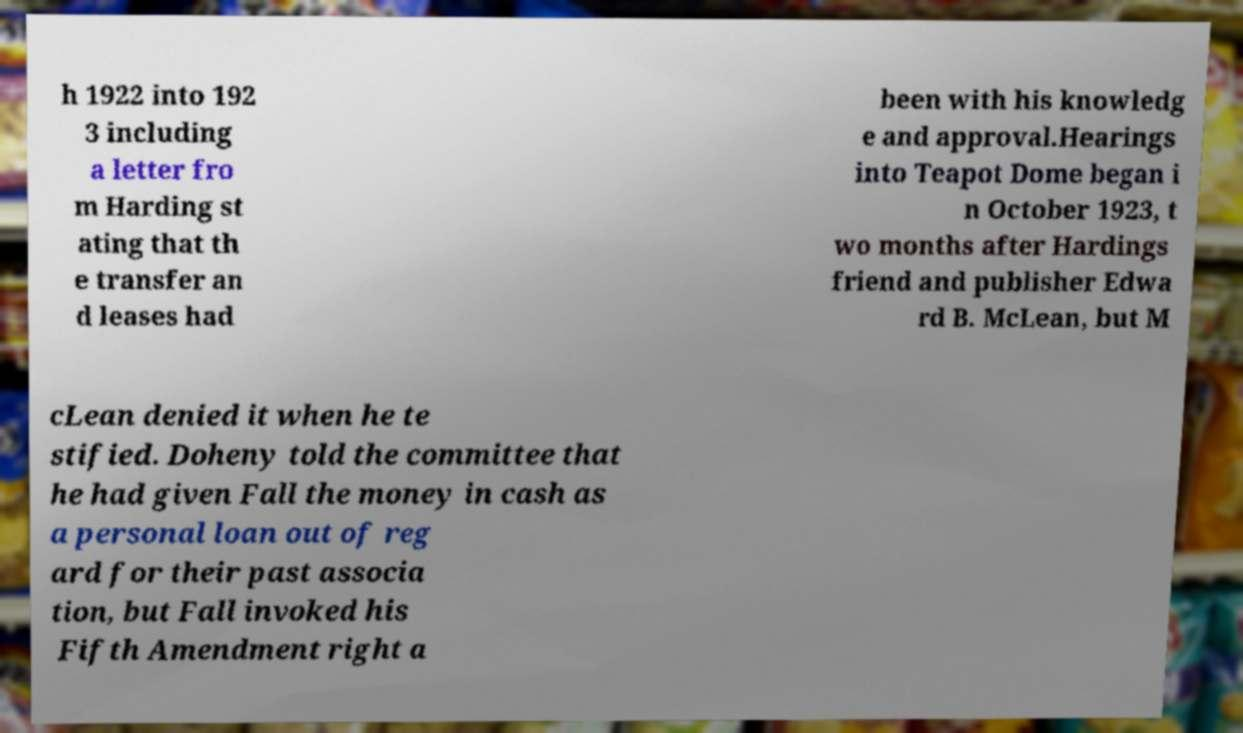Could you assist in decoding the text presented in this image and type it out clearly? h 1922 into 192 3 including a letter fro m Harding st ating that th e transfer an d leases had been with his knowledg e and approval.Hearings into Teapot Dome began i n October 1923, t wo months after Hardings friend and publisher Edwa rd B. McLean, but M cLean denied it when he te stified. Doheny told the committee that he had given Fall the money in cash as a personal loan out of reg ard for their past associa tion, but Fall invoked his Fifth Amendment right a 